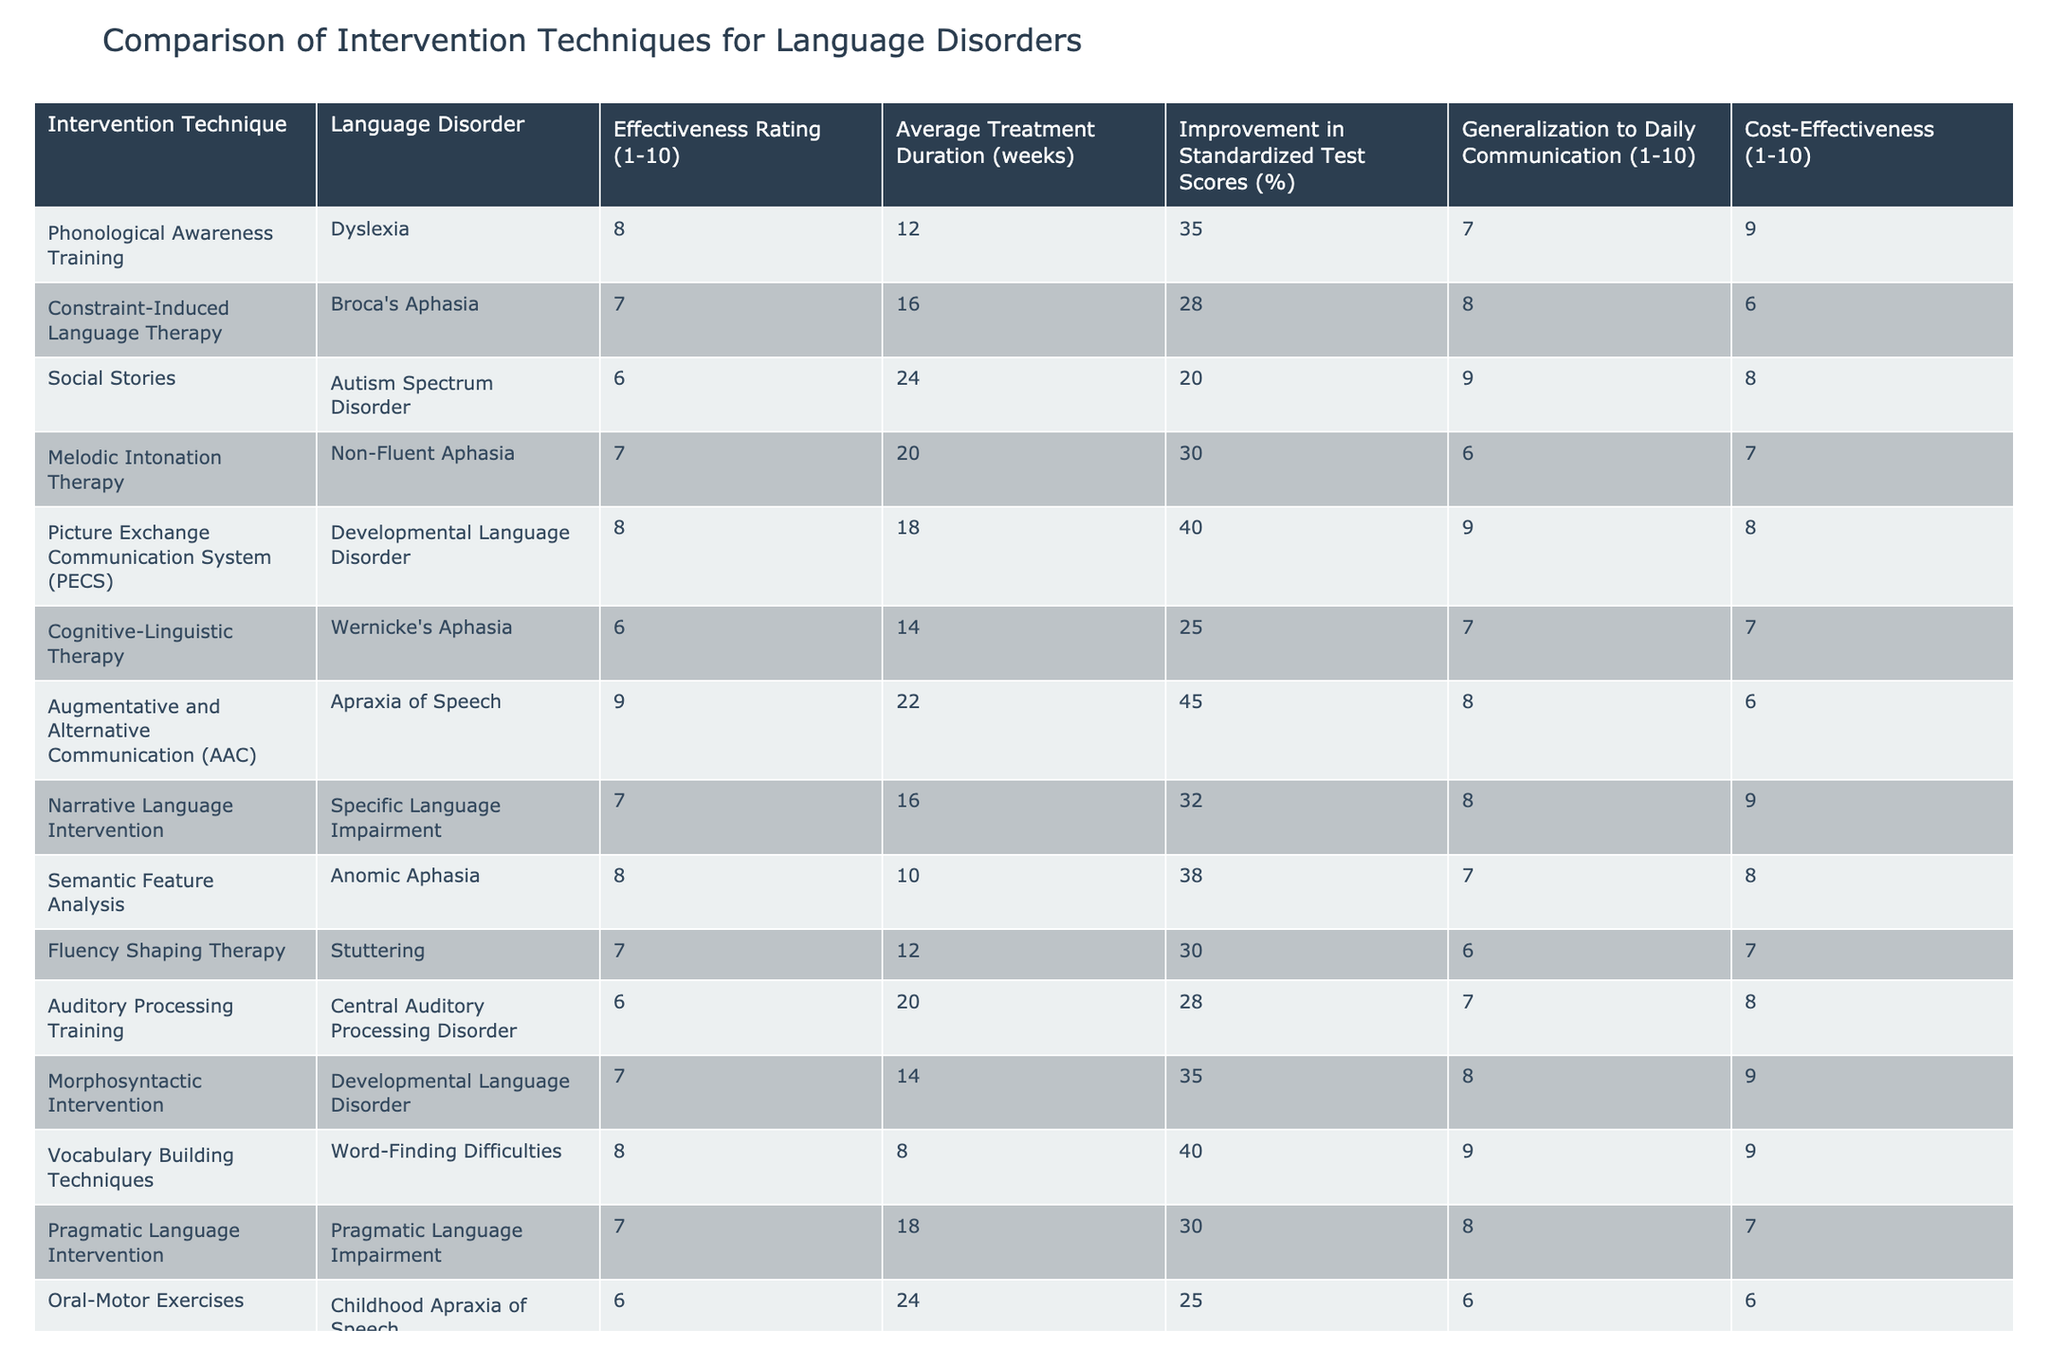What is the effectiveness rating for Phonological Awareness Training? The effectiveness rating for Phonological Awareness Training is provided directly in the table under the "Effectiveness Rating (1-10)" column. The value corresponding to this intervention technique is 8.
Answer: 8 Which intervention technique has the highest cost-effectiveness rating? The table shows that Augmentative and Alternative Communication (AAC) has a cost-effectiveness rating of 6, while Vocabulary Building Techniques has a rating of 9. Comparing the cost-effectiveness ratings of all intervention techniques, Vocabulary Building Techniques has the highest value of 9.
Answer: 9 What is the average improvement in standardized test scores across all interventions? To find the average improvement in standardized test scores, sum all the values from the "Improvement in Standardized Test Scores (%)" column: (35 + 28 + 20 + 30 + 40 + 25 + 45 + 32 + 38 + 30 + 28 + 35 + 40 + 30 + 25) = 409. Then, divide by the number of interventions (15): 409/15 ≈ 27.27.
Answer: 27.27 Does the Social Stories intervention have a generalization rating of 8 or higher? By examining the "Generalization to Daily Communication (1-10)" column, we see that Social Stories has a rating of 9. Since 9 is greater than 8, the statement is true.
Answer: Yes Which language disorder has the longest average treatment duration based on the table? The "Average Treatment Duration (weeks)" column shows the duration for each intervention technique. The longest duration is associated with Social Stories, which has an average treatment duration of 24 weeks, compared to others like AAC, which has 22 weeks. Hence, Social Stories has the longest duration.
Answer: Social Stories How many intervention techniques have an effectiveness rating of 7 or higher? The table must be scanned to count the number of intervention techniques with an effectiveness rating of 7 or higher. Those techniques with ratings of 8 or 7 are Phonological Awareness Training, Picture Exchange Communication System, Augmentative and Alternative Communication, Vocabulary Building Techniques, and a few others. A careful count shows there are 9 techniques in total.
Answer: 9 What is the difference in improvement percentage between the most and least effective interventions? The interventions with the highest and lowest improvement percentages are Augmentative and Alternative Communication (45%) and Social Stories (20%), respectively. The difference is calculated as 45% - 20% = 25%.
Answer: 25 Identify the intervention with the lowest effectiveness rating. By examining the "Effectiveness Rating (1-10)" column, I can see that both Oral-Motor Exercises and Cognitive-Linguistic Therapy have an effectiveness rating of 6, making them the lowest-rated interventions on the table.
Answer: 6 Is the average treatment duration for Pragmatic Language Intervention more than 18 weeks? Looking at the "Average Treatment Duration (weeks)" column, Pragmatic Language Intervention has a duration of 18 weeks. Since the duration is not greater than 18, the statement is false.
Answer: No 